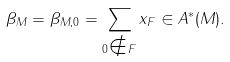<formula> <loc_0><loc_0><loc_500><loc_500>\beta _ { M } = \beta _ { M , 0 } = \sum _ { 0 \notin F } x _ { F } \in A ^ { * } ( M ) .</formula> 